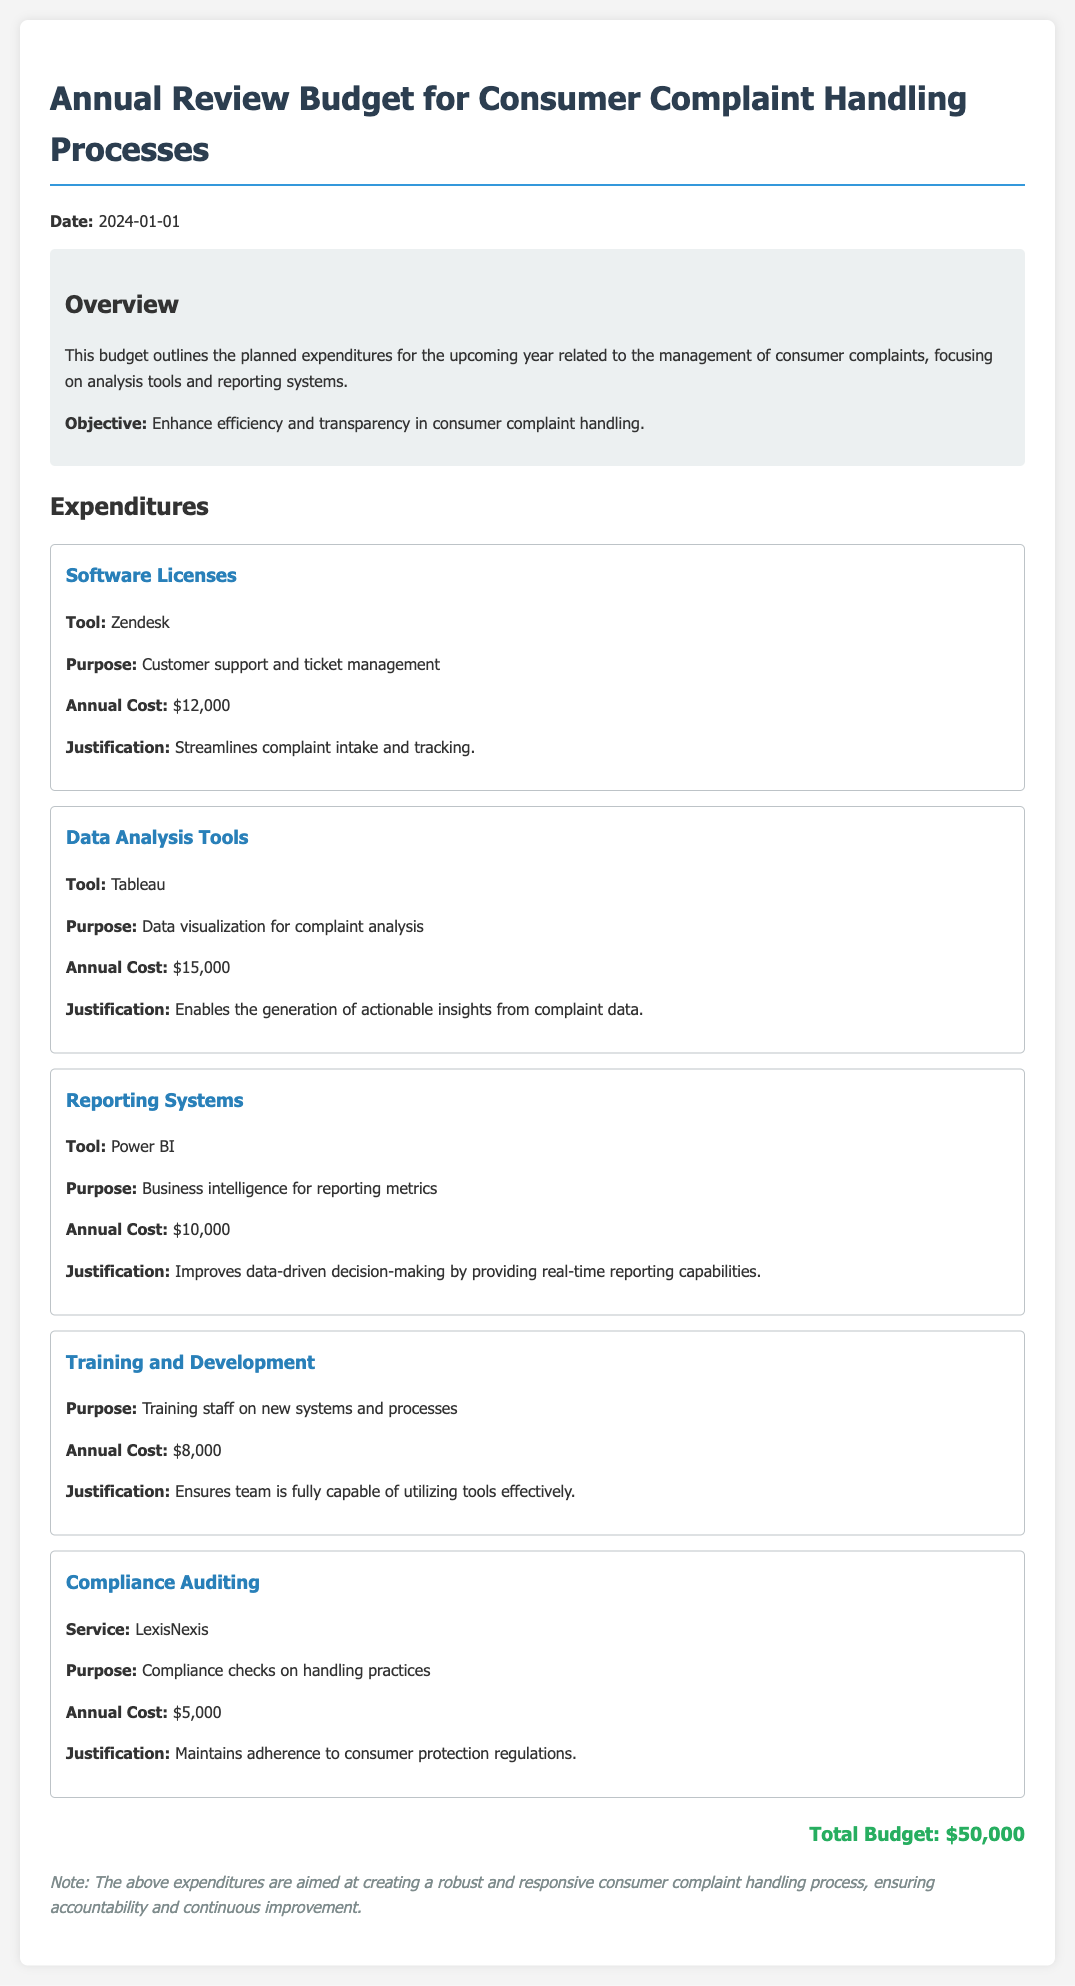what is the total budget? The total budget is the sum of all planned expenditures listed in the document.
Answer: $50,000 what is the annual cost for Tableau? The annual cost for Tableau is specifically mentioned under Data Analysis Tools in the expenditures section.
Answer: $15,000 what purpose does Zendesk serve? The purpose of Zendesk is described as customer support and ticket management in the document.
Answer: Customer support and ticket management how much is allocated for Compliance Auditing? The allocated amount for Compliance Auditing can be found in the breakdown of expenditures.
Answer: $5,000 what tool is listed for business intelligence reporting? The tool used for business intelligence reporting is stated in the Reporting Systems section of the document.
Answer: Power BI why is training and development included in the budget? The inclusion of training and development is justified by the need to train staff on new systems and processes.
Answer: To train staff on new systems and processes what is the annual cost for training and development? The document lists the annual cost for training and development.
Answer: $8,000 which tool helps with data visualization? The tool that assists with data visualization is mentioned under Data Analysis Tools.
Answer: Tableau what is the primary objective of the budget? The primary objective of the budget is summarized in the overview section.
Answer: Enhance efficiency and transparency in consumer complaint handling 